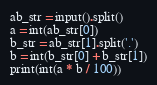<code> <loc_0><loc_0><loc_500><loc_500><_Python_>ab_str = input().split()
a = int(ab_str[0])
b_str = ab_str[1].split('.')
b = int(b_str[0] + b_str[1])
print(int(a * b / 100))
</code> 